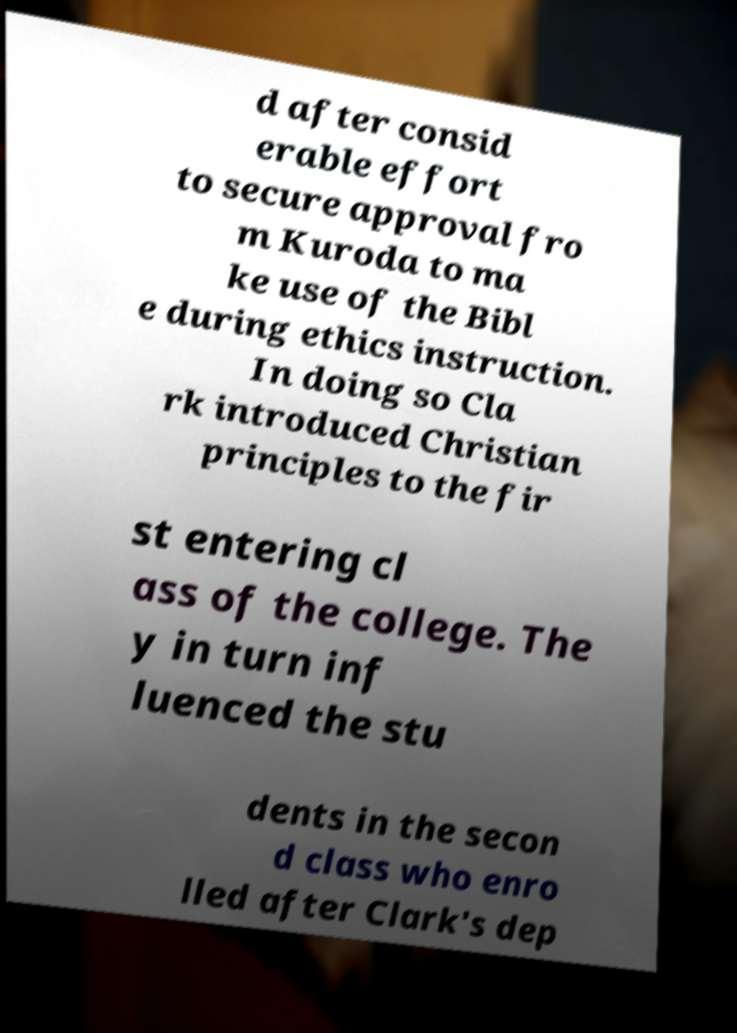Can you accurately transcribe the text from the provided image for me? d after consid erable effort to secure approval fro m Kuroda to ma ke use of the Bibl e during ethics instruction. In doing so Cla rk introduced Christian principles to the fir st entering cl ass of the college. The y in turn inf luenced the stu dents in the secon d class who enro lled after Clark's dep 